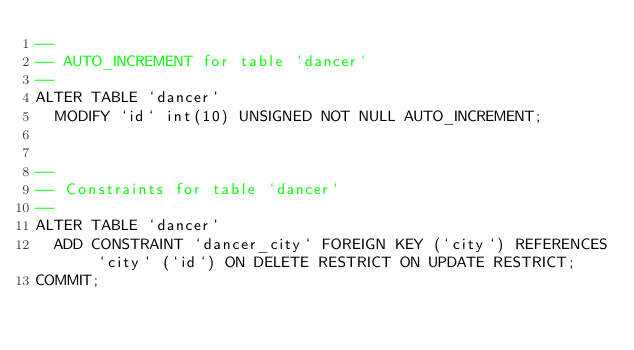<code> <loc_0><loc_0><loc_500><loc_500><_SQL_>--
-- AUTO_INCREMENT for table `dancer`
--
ALTER TABLE `dancer`
  MODIFY `id` int(10) UNSIGNED NOT NULL AUTO_INCREMENT;


--
-- Constraints for table `dancer`
--
ALTER TABLE `dancer`
  ADD CONSTRAINT `dancer_city` FOREIGN KEY (`city`) REFERENCES `city` (`id`) ON DELETE RESTRICT ON UPDATE RESTRICT;
COMMIT;
</code> 